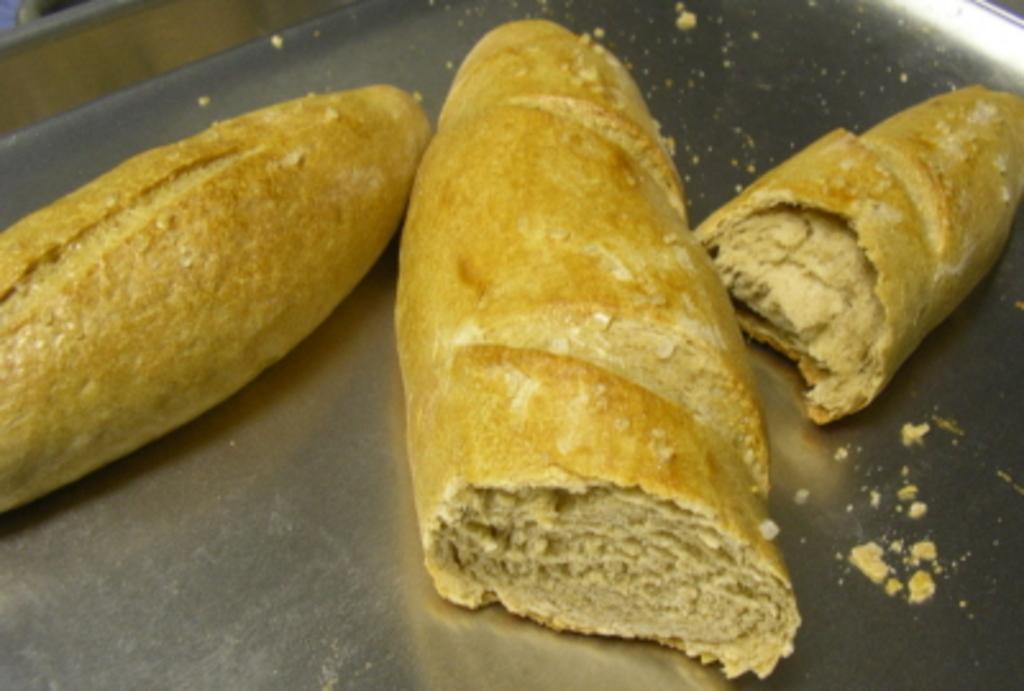In one or two sentences, can you explain what this image depicts? In this image there are some food items in a tray. 